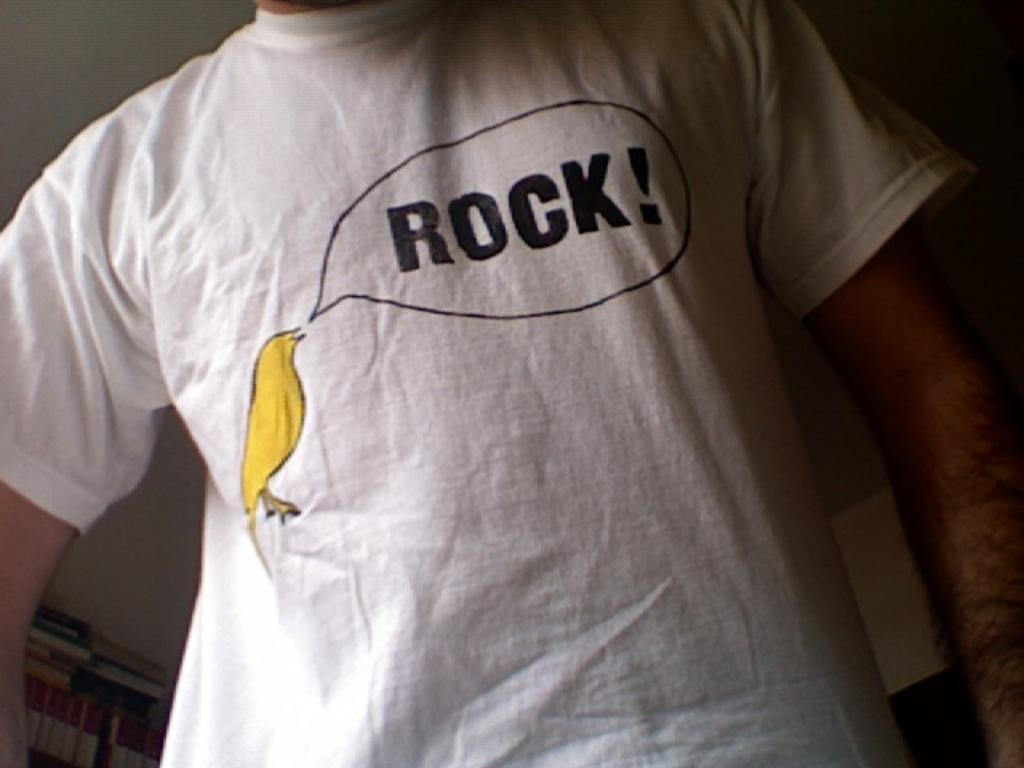<image>
Give a short and clear explanation of the subsequent image. A man wears a white T shirt with a canary that says, "Rock." 